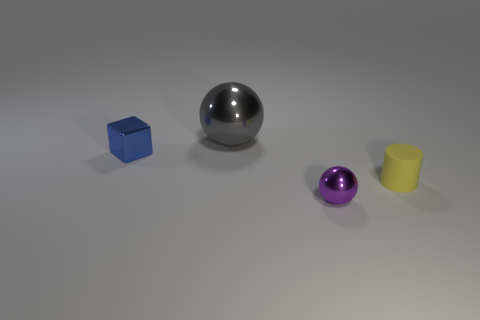Add 4 big gray matte balls. How many objects exist? 8 Subtract all gray balls. How many balls are left? 1 Subtract 1 cylinders. How many cylinders are left? 0 Subtract all brown blocks. Subtract all gray metallic things. How many objects are left? 3 Add 3 big balls. How many big balls are left? 4 Add 3 tiny balls. How many tiny balls exist? 4 Subtract 0 blue cylinders. How many objects are left? 4 Subtract all blocks. How many objects are left? 3 Subtract all brown cubes. Subtract all brown balls. How many cubes are left? 1 Subtract all gray cylinders. How many purple balls are left? 1 